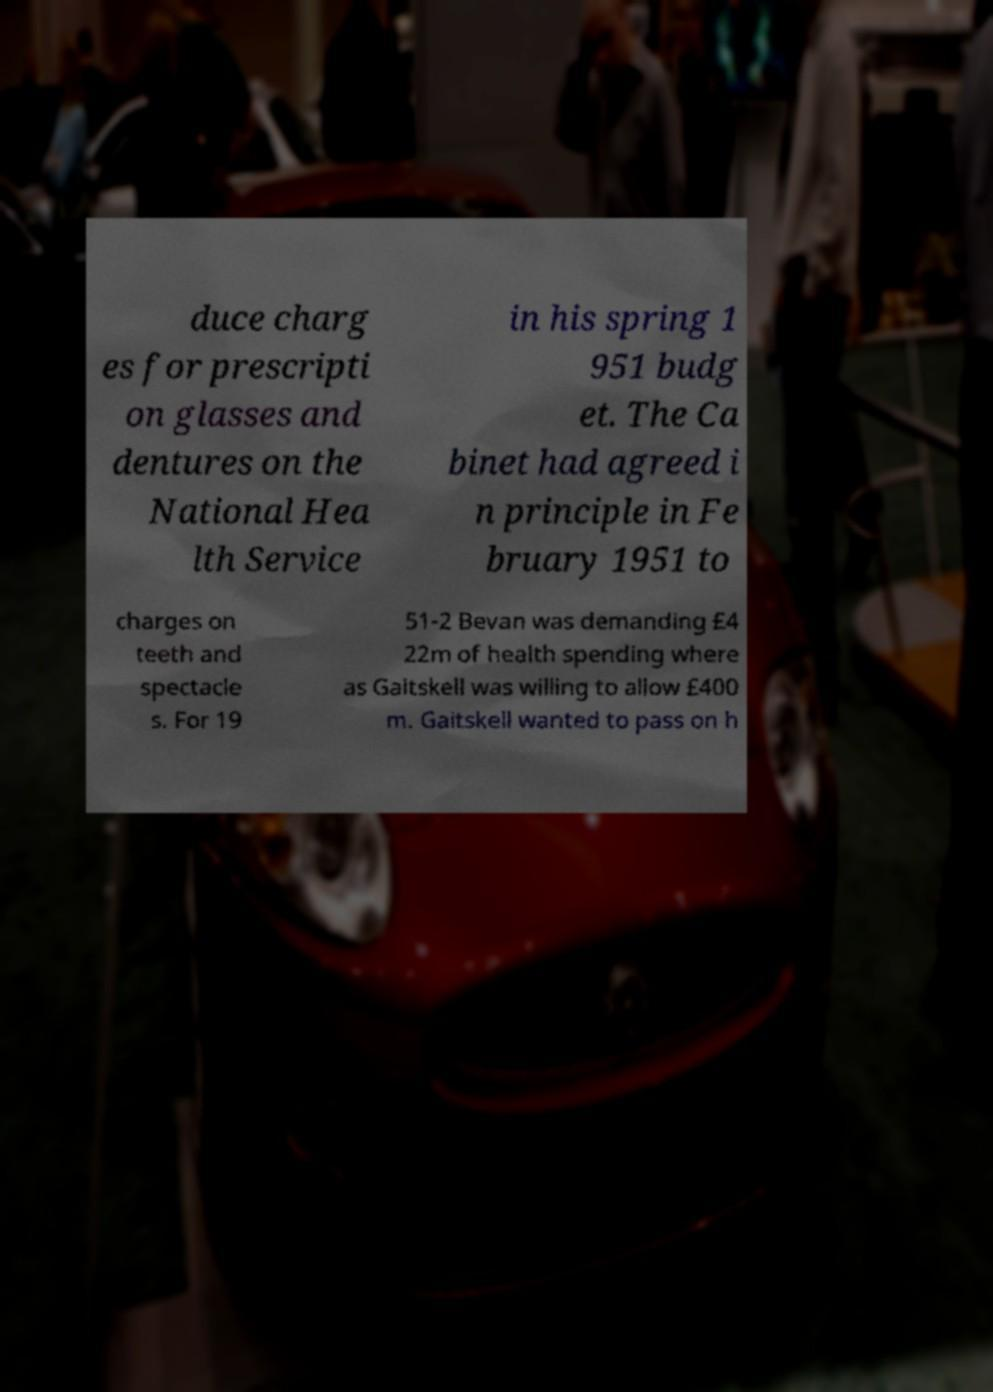Can you read and provide the text displayed in the image?This photo seems to have some interesting text. Can you extract and type it out for me? duce charg es for prescripti on glasses and dentures on the National Hea lth Service in his spring 1 951 budg et. The Ca binet had agreed i n principle in Fe bruary 1951 to charges on teeth and spectacle s. For 19 51-2 Bevan was demanding £4 22m of health spending where as Gaitskell was willing to allow £400 m. Gaitskell wanted to pass on h 